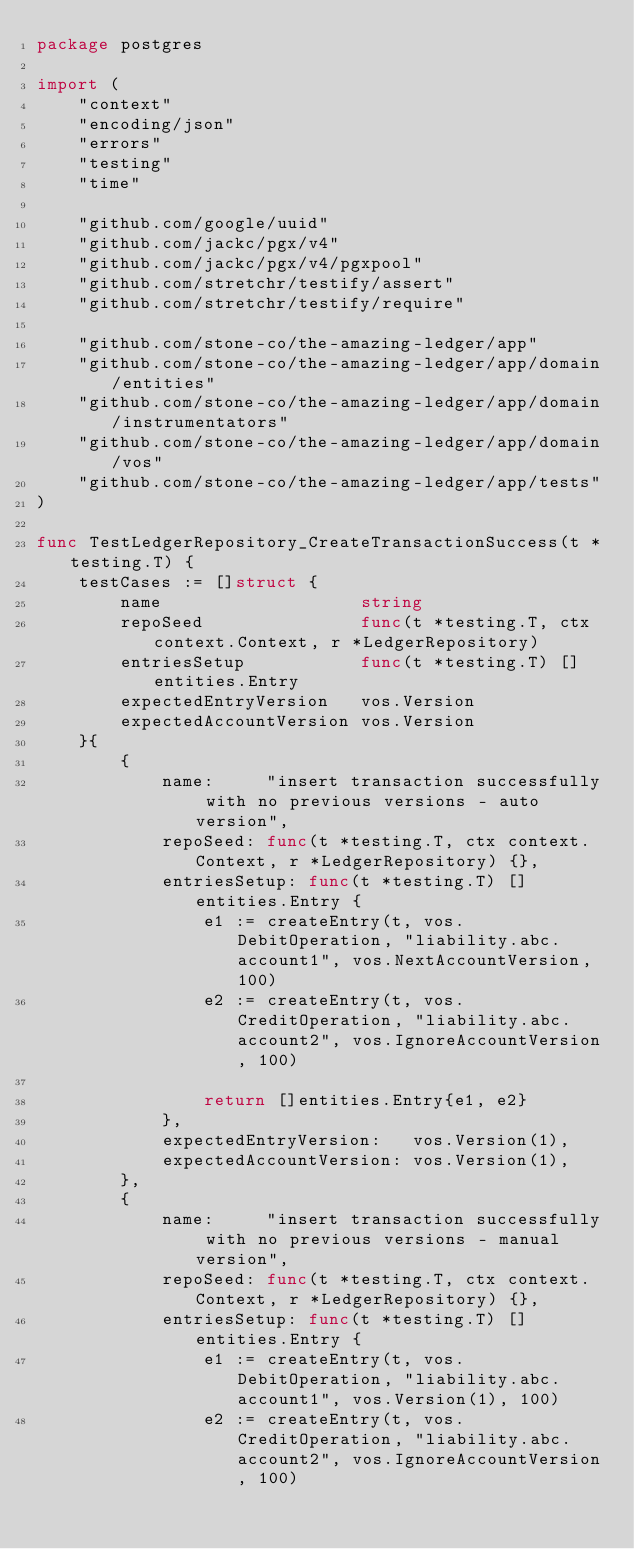Convert code to text. <code><loc_0><loc_0><loc_500><loc_500><_Go_>package postgres

import (
	"context"
	"encoding/json"
	"errors"
	"testing"
	"time"

	"github.com/google/uuid"
	"github.com/jackc/pgx/v4"
	"github.com/jackc/pgx/v4/pgxpool"
	"github.com/stretchr/testify/assert"
	"github.com/stretchr/testify/require"

	"github.com/stone-co/the-amazing-ledger/app"
	"github.com/stone-co/the-amazing-ledger/app/domain/entities"
	"github.com/stone-co/the-amazing-ledger/app/domain/instrumentators"
	"github.com/stone-co/the-amazing-ledger/app/domain/vos"
	"github.com/stone-co/the-amazing-ledger/app/tests"
)

func TestLedgerRepository_CreateTransactionSuccess(t *testing.T) {
	testCases := []struct {
		name                   string
		repoSeed               func(t *testing.T, ctx context.Context, r *LedgerRepository)
		entriesSetup           func(t *testing.T) []entities.Entry
		expectedEntryVersion   vos.Version
		expectedAccountVersion vos.Version
	}{
		{
			name:     "insert transaction successfully with no previous versions - auto version",
			repoSeed: func(t *testing.T, ctx context.Context, r *LedgerRepository) {},
			entriesSetup: func(t *testing.T) []entities.Entry {
				e1 := createEntry(t, vos.DebitOperation, "liability.abc.account1", vos.NextAccountVersion, 100)
				e2 := createEntry(t, vos.CreditOperation, "liability.abc.account2", vos.IgnoreAccountVersion, 100)

				return []entities.Entry{e1, e2}
			},
			expectedEntryVersion:   vos.Version(1),
			expectedAccountVersion: vos.Version(1),
		},
		{
			name:     "insert transaction successfully with no previous versions - manual version",
			repoSeed: func(t *testing.T, ctx context.Context, r *LedgerRepository) {},
			entriesSetup: func(t *testing.T) []entities.Entry {
				e1 := createEntry(t, vos.DebitOperation, "liability.abc.account1", vos.Version(1), 100)
				e2 := createEntry(t, vos.CreditOperation, "liability.abc.account2", vos.IgnoreAccountVersion, 100)
</code> 